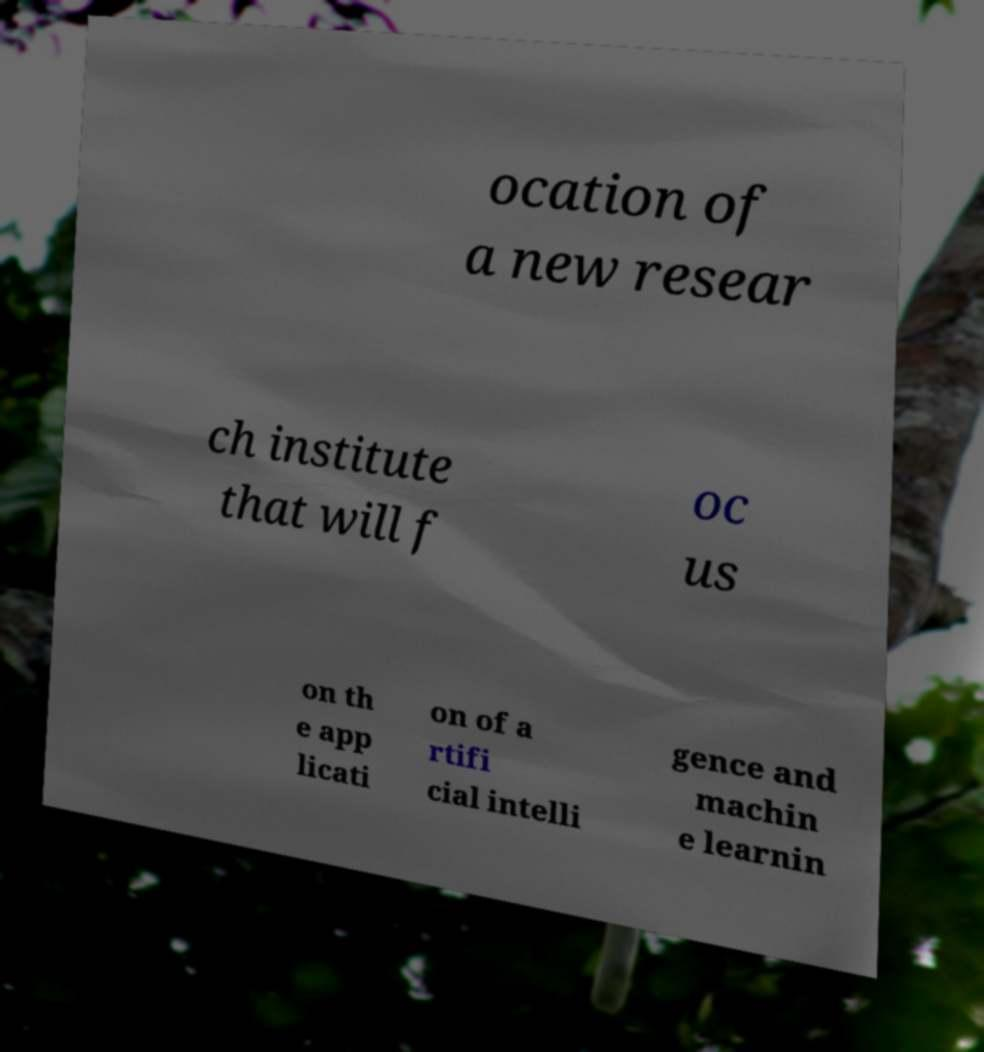Can you read and provide the text displayed in the image?This photo seems to have some interesting text. Can you extract and type it out for me? ocation of a new resear ch institute that will f oc us on th e app licati on of a rtifi cial intelli gence and machin e learnin 